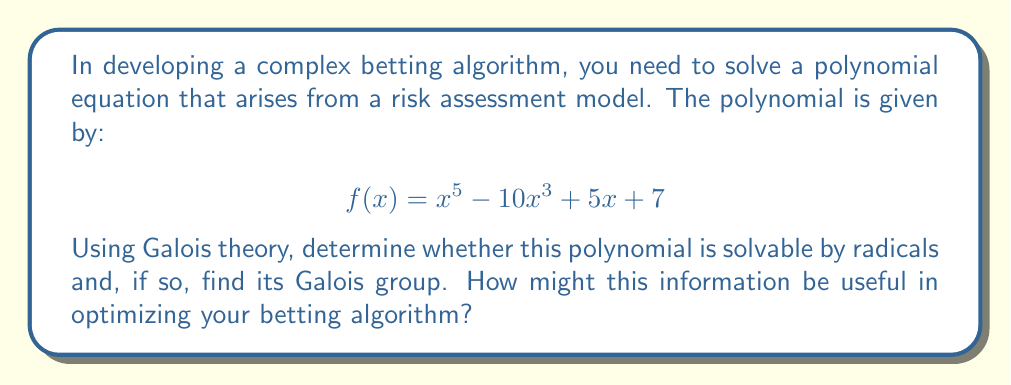Can you answer this question? To solve this problem using Galois theory, we'll follow these steps:

1) First, we need to determine if the polynomial is irreducible over $\mathbb{Q}$. We can use Eisenstein's criterion with the prime $p=7$:
   - $7$ divides all coefficients except the leading one
   - $7^2 = 49$ does not divide the constant term
   Therefore, $f(x)$ is irreducible over $\mathbb{Q}$.

2) Now, we need to determine the splitting field of $f(x)$. Let $E$ be the splitting field of $f(x)$ over $\mathbb{Q}$.

3) The degree of the extension $[E:\mathbb{Q}]$ divides $5!$ = 120, as it's a subgroup of $S_5$.

4) To determine the Galois group, we need to find the number of real roots of $f(x)$. By Descartes' rule of signs, $f(x)$ has either 1 or 3 real roots.

5) Using a computer algebra system or graphing calculator, we can verify that $f(x)$ has exactly one real root.

6) Since $f(x)$ has one real root and two pairs of complex conjugate roots, its Galois group must be a subgroup of $S_5$ that contains a 5-cycle (because $f(x)$ is irreducible) and an element of order 2 (for the complex conjugation).

7) The only subgroup of $S_5$ satisfying these conditions is $S_5$ itself.

Therefore, the Galois group of $f(x)$ is $S_5$.

8) Since $S_5$ is not a solvable group, $f(x)$ is not solvable by radicals.

This information can be useful in optimizing the betting algorithm in several ways:

a) It demonstrates that certain complex risk models may not have closed-form solutions, necessitating numerical methods.

b) The structure of the Galois group (in this case, $S_5$) can inform about the symmetries in the risk model, which might be exploited for computational efficiency.

c) Understanding the solvability of such equations can help in setting realistic expectations for the precision and computational complexity of the betting algorithm.
Answer: The polynomial $f(x) = x^5 - 10x^3 + 5x + 7$ is not solvable by radicals. Its Galois group is $S_5$, the symmetric group on 5 elements. 